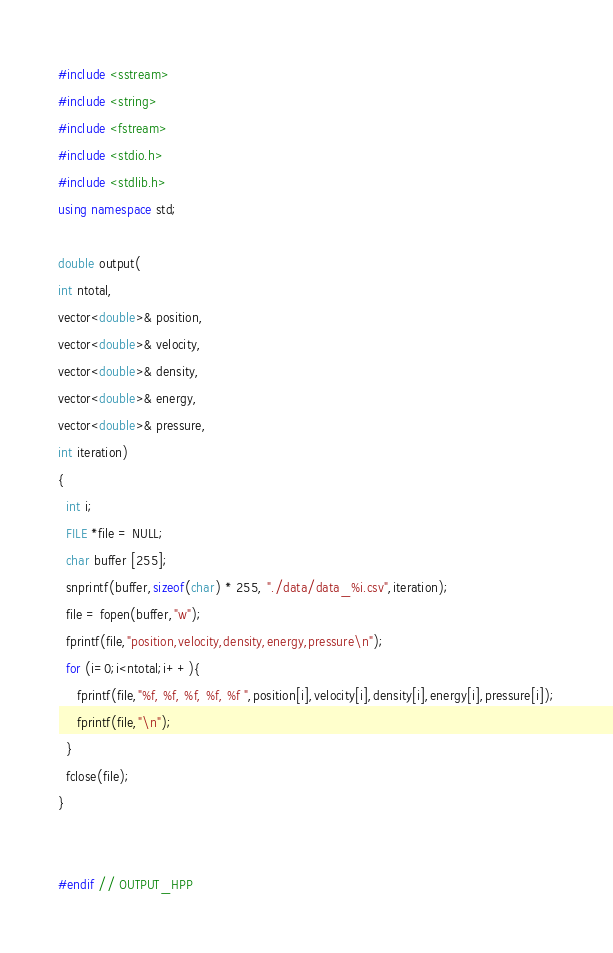<code> <loc_0><loc_0><loc_500><loc_500><_C++_>#include <sstream>
#include <string>
#include <fstream>
#include <stdio.h>
#include <stdlib.h>
using namespace std;

double output(
int ntotal,
vector<double>& position,
vector<double>& velocity,
vector<double>& density,
vector<double>& energy,
vector<double>& pressure,
int iteration)
{
  int i;
  FILE *file = NULL;
  char buffer [255];
  snprintf(buffer,sizeof(char) * 255, "./data/data_%i.csv",iteration);
  file = fopen(buffer,"w");
  fprintf(file,"position,velocity,density,energy,pressure\n");
  for (i=0;i<ntotal;i++){
     fprintf(file,"%f, %f, %f, %f, %f ",position[i],velocity[i],density[i],energy[i],pressure[i]);
     fprintf(file,"\n");
  }
  fclose(file);
}


#endif // OUTPUT_HPP
</code> 